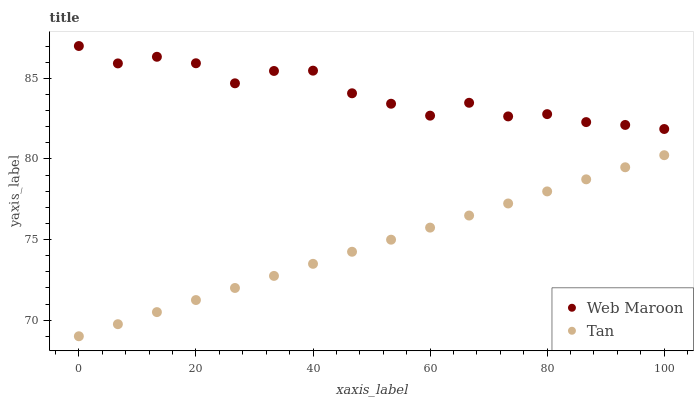Does Tan have the minimum area under the curve?
Answer yes or no. Yes. Does Web Maroon have the maximum area under the curve?
Answer yes or no. Yes. Does Web Maroon have the minimum area under the curve?
Answer yes or no. No. Is Tan the smoothest?
Answer yes or no. Yes. Is Web Maroon the roughest?
Answer yes or no. Yes. Is Web Maroon the smoothest?
Answer yes or no. No. Does Tan have the lowest value?
Answer yes or no. Yes. Does Web Maroon have the lowest value?
Answer yes or no. No. Does Web Maroon have the highest value?
Answer yes or no. Yes. Is Tan less than Web Maroon?
Answer yes or no. Yes. Is Web Maroon greater than Tan?
Answer yes or no. Yes. Does Tan intersect Web Maroon?
Answer yes or no. No. 